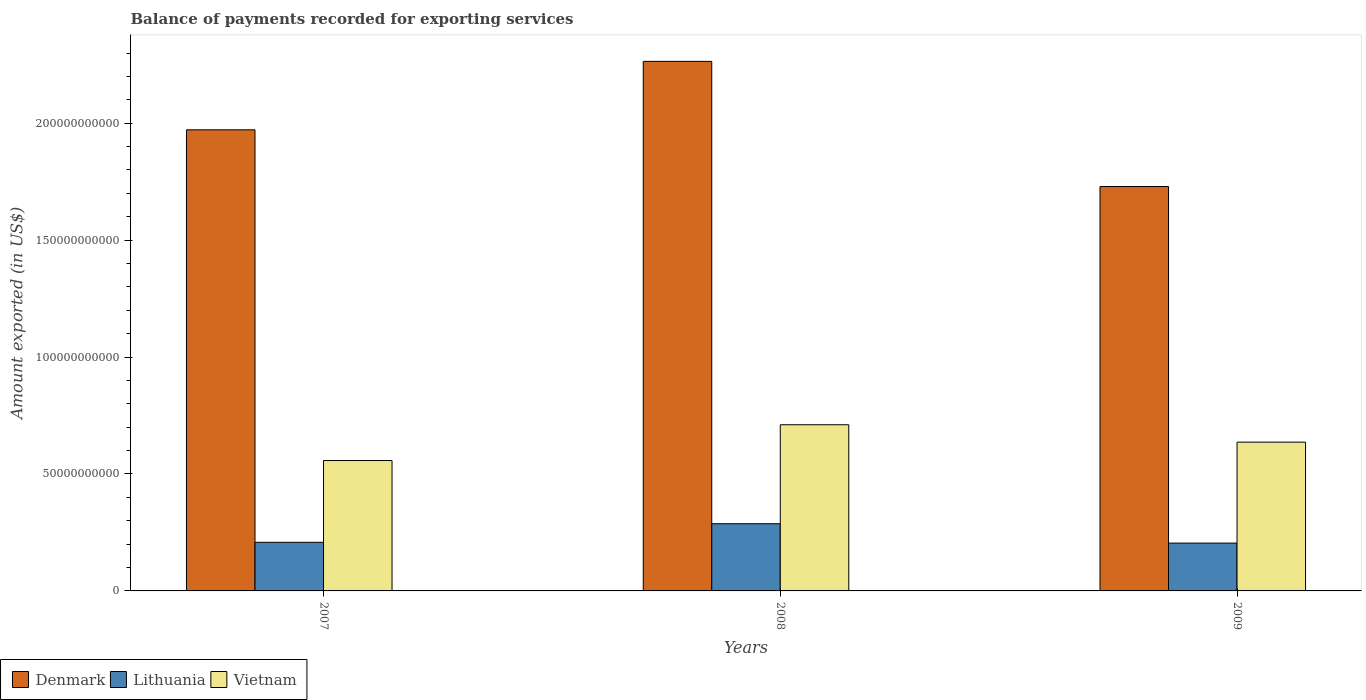How many different coloured bars are there?
Your answer should be compact. 3. How many bars are there on the 3rd tick from the left?
Provide a short and direct response. 3. In how many cases, is the number of bars for a given year not equal to the number of legend labels?
Offer a very short reply. 0. What is the amount exported in Denmark in 2009?
Ensure brevity in your answer.  1.73e+11. Across all years, what is the maximum amount exported in Vietnam?
Your answer should be compact. 7.10e+1. Across all years, what is the minimum amount exported in Vietnam?
Provide a succinct answer. 5.58e+1. What is the total amount exported in Denmark in the graph?
Provide a succinct answer. 5.97e+11. What is the difference between the amount exported in Lithuania in 2007 and that in 2009?
Make the answer very short. 3.30e+08. What is the difference between the amount exported in Lithuania in 2008 and the amount exported in Denmark in 2009?
Your response must be concise. -1.44e+11. What is the average amount exported in Vietnam per year?
Keep it short and to the point. 6.35e+1. In the year 2007, what is the difference between the amount exported in Vietnam and amount exported in Denmark?
Offer a very short reply. -1.41e+11. What is the ratio of the amount exported in Vietnam in 2007 to that in 2008?
Keep it short and to the point. 0.78. What is the difference between the highest and the second highest amount exported in Denmark?
Keep it short and to the point. 2.93e+1. What is the difference between the highest and the lowest amount exported in Lithuania?
Make the answer very short. 8.28e+09. Is the sum of the amount exported in Lithuania in 2007 and 2009 greater than the maximum amount exported in Denmark across all years?
Your answer should be very brief. No. What does the 2nd bar from the left in 2007 represents?
Your answer should be compact. Lithuania. How many bars are there?
Give a very brief answer. 9. Are all the bars in the graph horizontal?
Give a very brief answer. No. Does the graph contain grids?
Provide a succinct answer. No. Where does the legend appear in the graph?
Ensure brevity in your answer.  Bottom left. How many legend labels are there?
Your response must be concise. 3. What is the title of the graph?
Offer a very short reply. Balance of payments recorded for exporting services. What is the label or title of the Y-axis?
Make the answer very short. Amount exported (in US$). What is the Amount exported (in US$) of Denmark in 2007?
Offer a very short reply. 1.97e+11. What is the Amount exported (in US$) in Lithuania in 2007?
Provide a short and direct response. 2.08e+1. What is the Amount exported (in US$) in Vietnam in 2007?
Your response must be concise. 5.58e+1. What is the Amount exported (in US$) of Denmark in 2008?
Your answer should be compact. 2.26e+11. What is the Amount exported (in US$) in Lithuania in 2008?
Provide a succinct answer. 2.87e+1. What is the Amount exported (in US$) of Vietnam in 2008?
Offer a terse response. 7.10e+1. What is the Amount exported (in US$) of Denmark in 2009?
Give a very brief answer. 1.73e+11. What is the Amount exported (in US$) of Lithuania in 2009?
Make the answer very short. 2.04e+1. What is the Amount exported (in US$) in Vietnam in 2009?
Provide a short and direct response. 6.36e+1. Across all years, what is the maximum Amount exported (in US$) in Denmark?
Keep it short and to the point. 2.26e+11. Across all years, what is the maximum Amount exported (in US$) of Lithuania?
Make the answer very short. 2.87e+1. Across all years, what is the maximum Amount exported (in US$) of Vietnam?
Your answer should be compact. 7.10e+1. Across all years, what is the minimum Amount exported (in US$) of Denmark?
Your answer should be very brief. 1.73e+11. Across all years, what is the minimum Amount exported (in US$) of Lithuania?
Your answer should be very brief. 2.04e+1. Across all years, what is the minimum Amount exported (in US$) in Vietnam?
Give a very brief answer. 5.58e+1. What is the total Amount exported (in US$) of Denmark in the graph?
Offer a terse response. 5.97e+11. What is the total Amount exported (in US$) in Lithuania in the graph?
Ensure brevity in your answer.  7.00e+1. What is the total Amount exported (in US$) of Vietnam in the graph?
Offer a terse response. 1.90e+11. What is the difference between the Amount exported (in US$) of Denmark in 2007 and that in 2008?
Offer a very short reply. -2.93e+1. What is the difference between the Amount exported (in US$) in Lithuania in 2007 and that in 2008?
Provide a short and direct response. -7.95e+09. What is the difference between the Amount exported (in US$) of Vietnam in 2007 and that in 2008?
Keep it short and to the point. -1.53e+1. What is the difference between the Amount exported (in US$) of Denmark in 2007 and that in 2009?
Offer a very short reply. 2.42e+1. What is the difference between the Amount exported (in US$) of Lithuania in 2007 and that in 2009?
Keep it short and to the point. 3.30e+08. What is the difference between the Amount exported (in US$) in Vietnam in 2007 and that in 2009?
Your answer should be very brief. -7.86e+09. What is the difference between the Amount exported (in US$) in Denmark in 2008 and that in 2009?
Offer a terse response. 5.35e+1. What is the difference between the Amount exported (in US$) in Lithuania in 2008 and that in 2009?
Ensure brevity in your answer.  8.28e+09. What is the difference between the Amount exported (in US$) of Vietnam in 2008 and that in 2009?
Your answer should be compact. 7.43e+09. What is the difference between the Amount exported (in US$) in Denmark in 2007 and the Amount exported (in US$) in Lithuania in 2008?
Your answer should be very brief. 1.68e+11. What is the difference between the Amount exported (in US$) of Denmark in 2007 and the Amount exported (in US$) of Vietnam in 2008?
Keep it short and to the point. 1.26e+11. What is the difference between the Amount exported (in US$) of Lithuania in 2007 and the Amount exported (in US$) of Vietnam in 2008?
Provide a short and direct response. -5.03e+1. What is the difference between the Amount exported (in US$) in Denmark in 2007 and the Amount exported (in US$) in Lithuania in 2009?
Keep it short and to the point. 1.77e+11. What is the difference between the Amount exported (in US$) in Denmark in 2007 and the Amount exported (in US$) in Vietnam in 2009?
Your response must be concise. 1.34e+11. What is the difference between the Amount exported (in US$) of Lithuania in 2007 and the Amount exported (in US$) of Vietnam in 2009?
Provide a short and direct response. -4.28e+1. What is the difference between the Amount exported (in US$) of Denmark in 2008 and the Amount exported (in US$) of Lithuania in 2009?
Provide a short and direct response. 2.06e+11. What is the difference between the Amount exported (in US$) of Denmark in 2008 and the Amount exported (in US$) of Vietnam in 2009?
Your response must be concise. 1.63e+11. What is the difference between the Amount exported (in US$) of Lithuania in 2008 and the Amount exported (in US$) of Vietnam in 2009?
Ensure brevity in your answer.  -3.49e+1. What is the average Amount exported (in US$) of Denmark per year?
Offer a very short reply. 1.99e+11. What is the average Amount exported (in US$) of Lithuania per year?
Offer a terse response. 2.33e+1. What is the average Amount exported (in US$) of Vietnam per year?
Provide a short and direct response. 6.35e+1. In the year 2007, what is the difference between the Amount exported (in US$) in Denmark and Amount exported (in US$) in Lithuania?
Ensure brevity in your answer.  1.76e+11. In the year 2007, what is the difference between the Amount exported (in US$) in Denmark and Amount exported (in US$) in Vietnam?
Your answer should be compact. 1.41e+11. In the year 2007, what is the difference between the Amount exported (in US$) of Lithuania and Amount exported (in US$) of Vietnam?
Your answer should be compact. -3.50e+1. In the year 2008, what is the difference between the Amount exported (in US$) in Denmark and Amount exported (in US$) in Lithuania?
Your response must be concise. 1.98e+11. In the year 2008, what is the difference between the Amount exported (in US$) of Denmark and Amount exported (in US$) of Vietnam?
Keep it short and to the point. 1.55e+11. In the year 2008, what is the difference between the Amount exported (in US$) in Lithuania and Amount exported (in US$) in Vietnam?
Make the answer very short. -4.23e+1. In the year 2009, what is the difference between the Amount exported (in US$) of Denmark and Amount exported (in US$) of Lithuania?
Make the answer very short. 1.52e+11. In the year 2009, what is the difference between the Amount exported (in US$) in Denmark and Amount exported (in US$) in Vietnam?
Provide a succinct answer. 1.09e+11. In the year 2009, what is the difference between the Amount exported (in US$) in Lithuania and Amount exported (in US$) in Vietnam?
Give a very brief answer. -4.32e+1. What is the ratio of the Amount exported (in US$) of Denmark in 2007 to that in 2008?
Offer a very short reply. 0.87. What is the ratio of the Amount exported (in US$) of Lithuania in 2007 to that in 2008?
Provide a short and direct response. 0.72. What is the ratio of the Amount exported (in US$) of Vietnam in 2007 to that in 2008?
Your response must be concise. 0.78. What is the ratio of the Amount exported (in US$) in Denmark in 2007 to that in 2009?
Offer a very short reply. 1.14. What is the ratio of the Amount exported (in US$) in Lithuania in 2007 to that in 2009?
Give a very brief answer. 1.02. What is the ratio of the Amount exported (in US$) in Vietnam in 2007 to that in 2009?
Provide a succinct answer. 0.88. What is the ratio of the Amount exported (in US$) in Denmark in 2008 to that in 2009?
Keep it short and to the point. 1.31. What is the ratio of the Amount exported (in US$) in Lithuania in 2008 to that in 2009?
Offer a very short reply. 1.41. What is the ratio of the Amount exported (in US$) in Vietnam in 2008 to that in 2009?
Offer a very short reply. 1.12. What is the difference between the highest and the second highest Amount exported (in US$) in Denmark?
Your answer should be very brief. 2.93e+1. What is the difference between the highest and the second highest Amount exported (in US$) of Lithuania?
Your response must be concise. 7.95e+09. What is the difference between the highest and the second highest Amount exported (in US$) of Vietnam?
Offer a very short reply. 7.43e+09. What is the difference between the highest and the lowest Amount exported (in US$) in Denmark?
Give a very brief answer. 5.35e+1. What is the difference between the highest and the lowest Amount exported (in US$) in Lithuania?
Offer a terse response. 8.28e+09. What is the difference between the highest and the lowest Amount exported (in US$) of Vietnam?
Your response must be concise. 1.53e+1. 